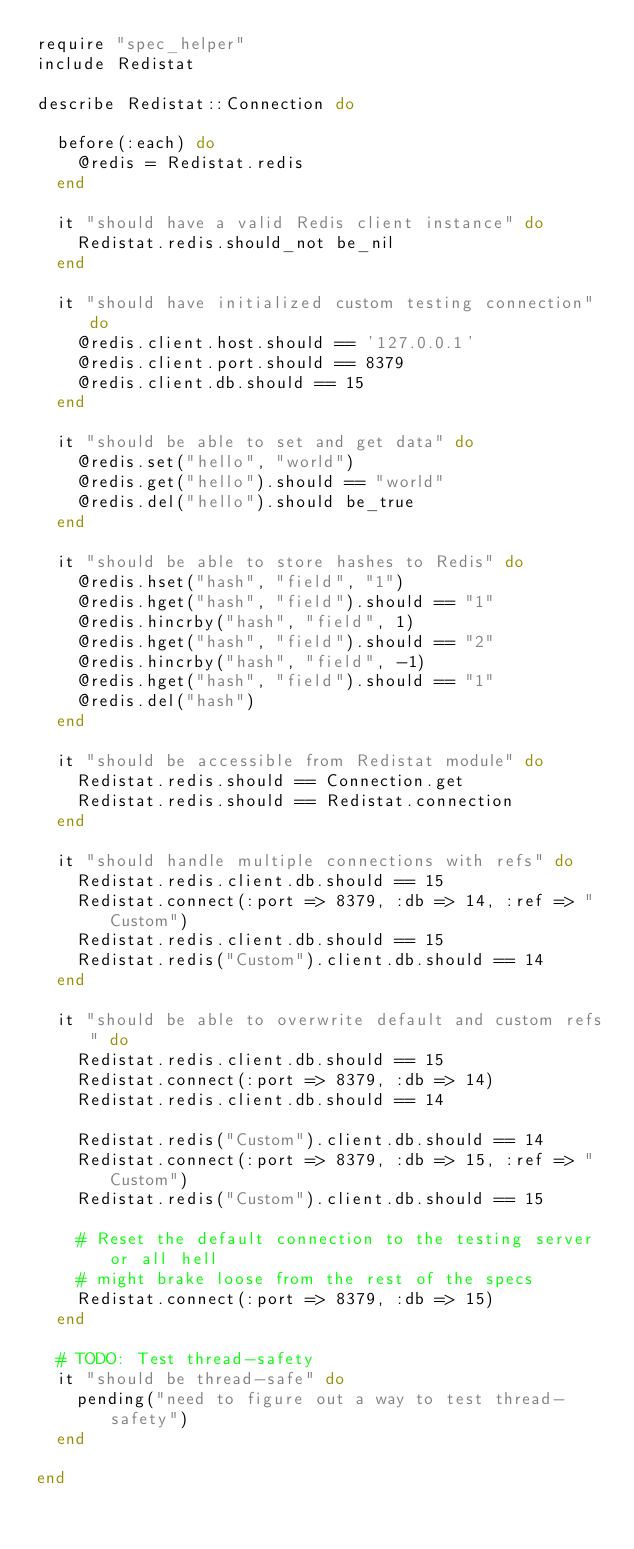Convert code to text. <code><loc_0><loc_0><loc_500><loc_500><_Ruby_>require "spec_helper"
include Redistat

describe Redistat::Connection do

  before(:each) do
    @redis = Redistat.redis
  end

  it "should have a valid Redis client instance" do
    Redistat.redis.should_not be_nil
  end

  it "should have initialized custom testing connection" do
    @redis.client.host.should == '127.0.0.1'
    @redis.client.port.should == 8379
    @redis.client.db.should == 15
  end

  it "should be able to set and get data" do
    @redis.set("hello", "world")
    @redis.get("hello").should == "world"
    @redis.del("hello").should be_true
  end

  it "should be able to store hashes to Redis" do
    @redis.hset("hash", "field", "1")
    @redis.hget("hash", "field").should == "1"
    @redis.hincrby("hash", "field", 1)
    @redis.hget("hash", "field").should == "2"
    @redis.hincrby("hash", "field", -1)
    @redis.hget("hash", "field").should == "1"
    @redis.del("hash")
  end

  it "should be accessible from Redistat module" do
    Redistat.redis.should == Connection.get
    Redistat.redis.should == Redistat.connection
  end

  it "should handle multiple connections with refs" do
    Redistat.redis.client.db.should == 15
    Redistat.connect(:port => 8379, :db => 14, :ref => "Custom")
    Redistat.redis.client.db.should == 15
    Redistat.redis("Custom").client.db.should == 14
  end

  it "should be able to overwrite default and custom refs" do
    Redistat.redis.client.db.should == 15
    Redistat.connect(:port => 8379, :db => 14)
    Redistat.redis.client.db.should == 14

    Redistat.redis("Custom").client.db.should == 14
    Redistat.connect(:port => 8379, :db => 15, :ref => "Custom")
    Redistat.redis("Custom").client.db.should == 15

    # Reset the default connection to the testing server or all hell
    # might brake loose from the rest of the specs
    Redistat.connect(:port => 8379, :db => 15)
  end

  # TODO: Test thread-safety
  it "should be thread-safe" do
    pending("need to figure out a way to test thread-safety")
  end

end
</code> 